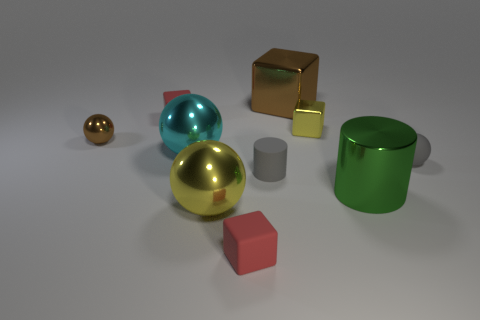Is the number of brown metallic blocks on the right side of the large cube the same as the number of brown balls?
Make the answer very short. No. Is there any other thing that is the same size as the green cylinder?
Provide a short and direct response. Yes. There is a red thing behind the brown object to the left of the gray rubber cylinder; what is it made of?
Make the answer very short. Rubber. There is a object that is both behind the green metal thing and on the right side of the tiny yellow metallic block; what is its shape?
Provide a short and direct response. Sphere. The yellow metal object that is the same shape as the small brown thing is what size?
Your answer should be compact. Large. Is the number of metallic cylinders on the left side of the large green metallic thing less than the number of large cyan balls?
Your response must be concise. Yes. What is the size of the yellow metallic thing behind the green cylinder?
Give a very brief answer. Small. What is the color of the other small rubber thing that is the same shape as the cyan object?
Provide a succinct answer. Gray. How many tiny rubber cylinders are the same color as the small metal block?
Give a very brief answer. 0. Are there any other things that have the same shape as the big yellow thing?
Your answer should be compact. Yes. 